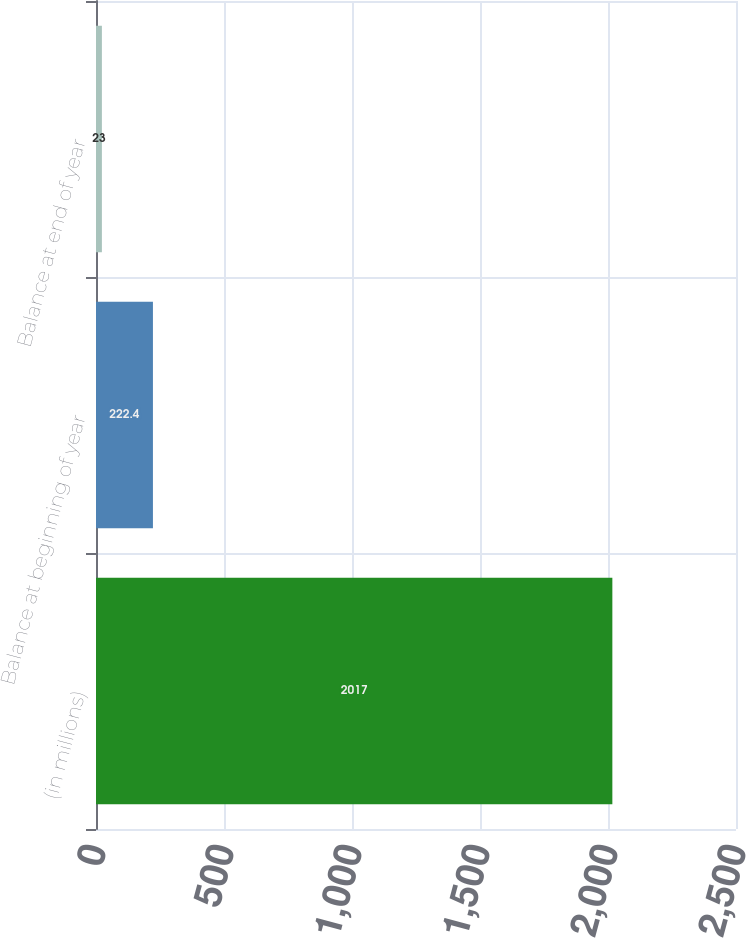<chart> <loc_0><loc_0><loc_500><loc_500><bar_chart><fcel>(in millions)<fcel>Balance at beginning of year<fcel>Balance at end of year<nl><fcel>2017<fcel>222.4<fcel>23<nl></chart> 